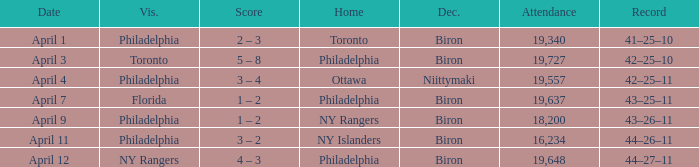Who were the visitors when the home team were the ny rangers? Philadelphia. 